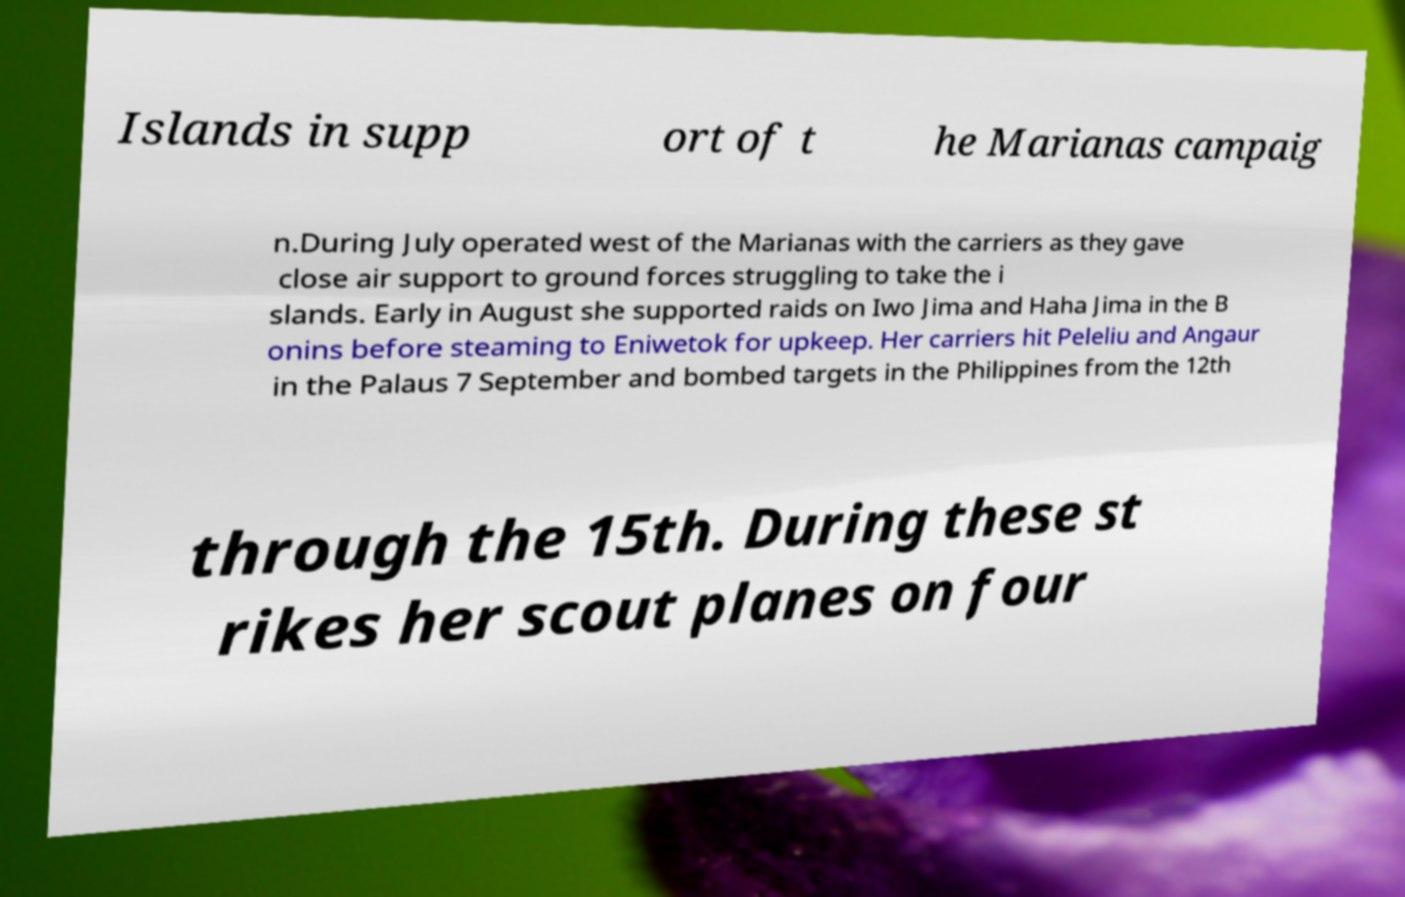Please read and relay the text visible in this image. What does it say? Islands in supp ort of t he Marianas campaig n.During July operated west of the Marianas with the carriers as they gave close air support to ground forces struggling to take the i slands. Early in August she supported raids on Iwo Jima and Haha Jima in the B onins before steaming to Eniwetok for upkeep. Her carriers hit Peleliu and Angaur in the Palaus 7 September and bombed targets in the Philippines from the 12th through the 15th. During these st rikes her scout planes on four 